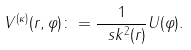Convert formula to latex. <formula><loc_0><loc_0><loc_500><loc_500>V ^ { ( \kappa ) } ( r , \varphi ) \colon = \frac { 1 } { \ s k ^ { 2 } ( r ) } U ( \varphi ) .</formula> 